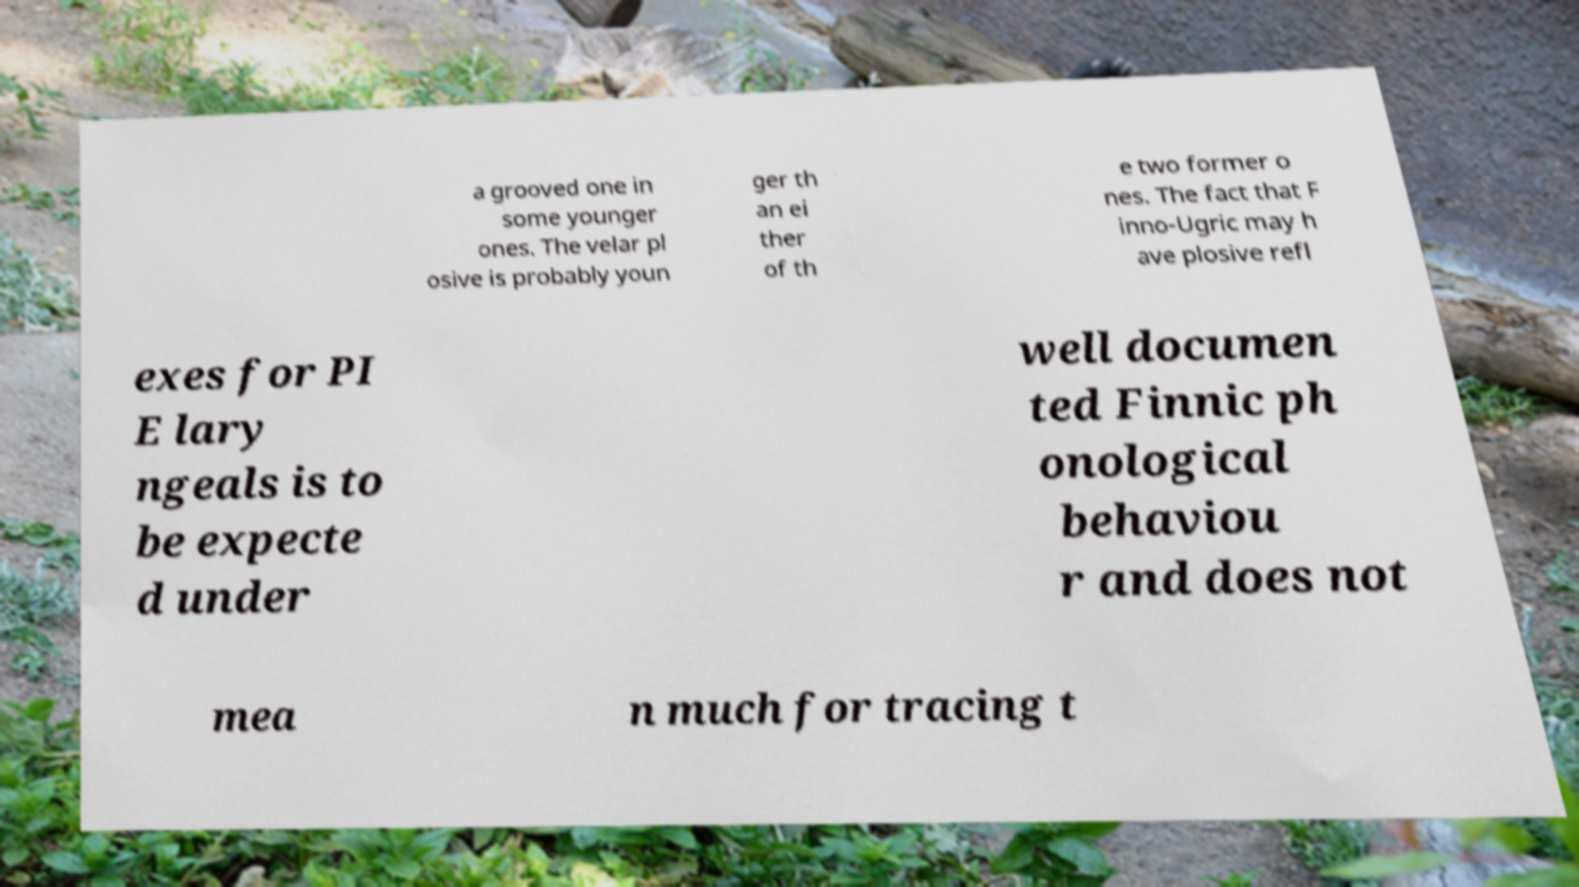For documentation purposes, I need the text within this image transcribed. Could you provide that? a grooved one in some younger ones. The velar pl osive is probably youn ger th an ei ther of th e two former o nes. The fact that F inno-Ugric may h ave plosive refl exes for PI E lary ngeals is to be expecte d under well documen ted Finnic ph onological behaviou r and does not mea n much for tracing t 